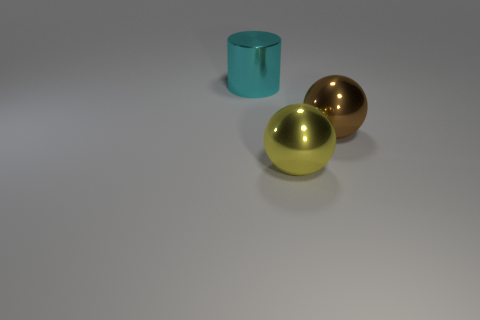Are these objects usually seen together like this? Not typically in everyday settings, as they appear to be stylistic representations or models, possibly used for display or educational purposes to illustrate geometry or light interaction, rather than functional household or industrial items. 